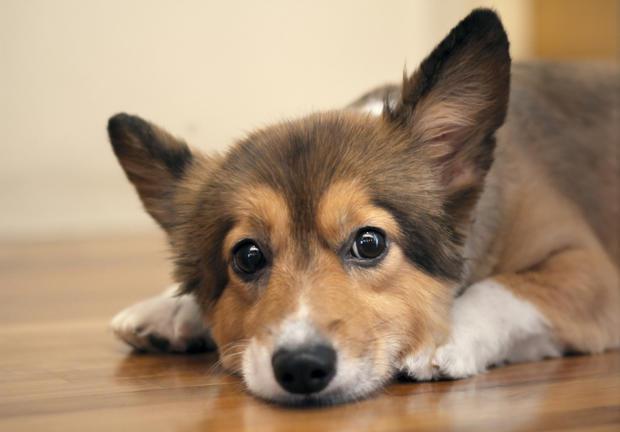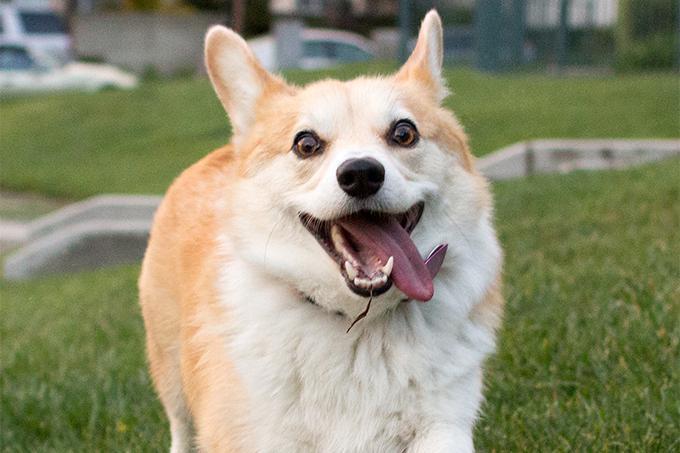The first image is the image on the left, the second image is the image on the right. Evaluate the accuracy of this statement regarding the images: "The right image includes a tan and white dog that is sitting upright on a white background.". Is it true? Answer yes or no. No. The first image is the image on the left, the second image is the image on the right. For the images displayed, is the sentence "Two corgies with similar tan coloring and ears standing up have smiling expressions and tongues hanging out." factually correct? Answer yes or no. No. 